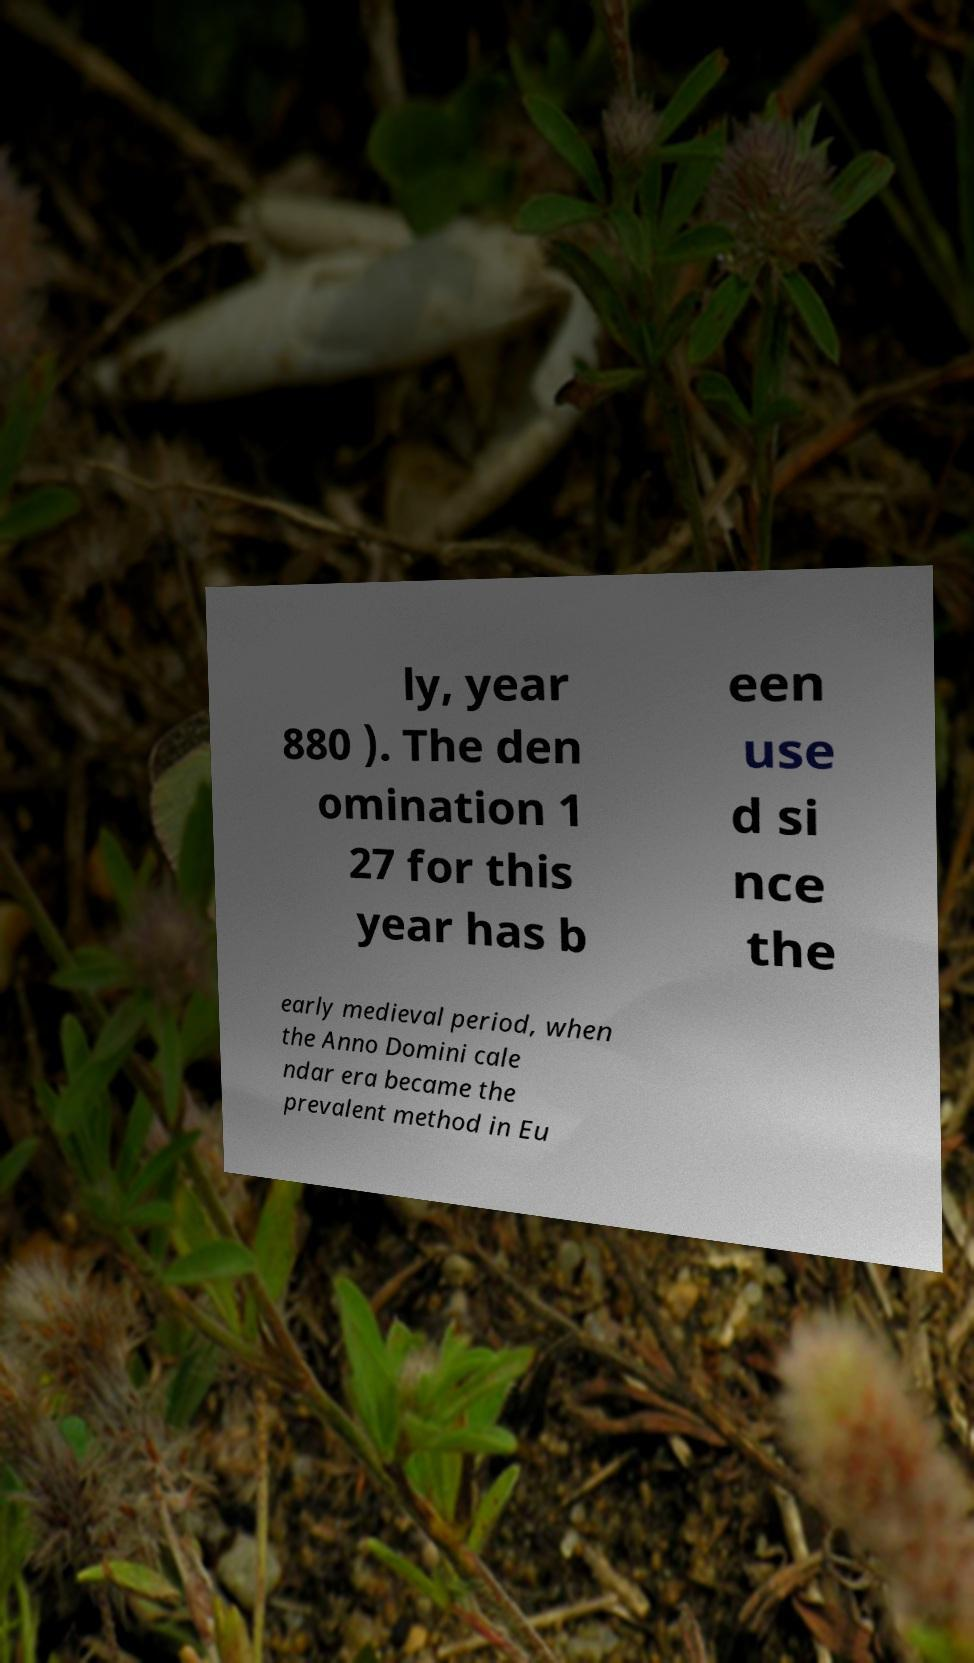Please identify and transcribe the text found in this image. ly, year 880 ). The den omination 1 27 for this year has b een use d si nce the early medieval period, when the Anno Domini cale ndar era became the prevalent method in Eu 